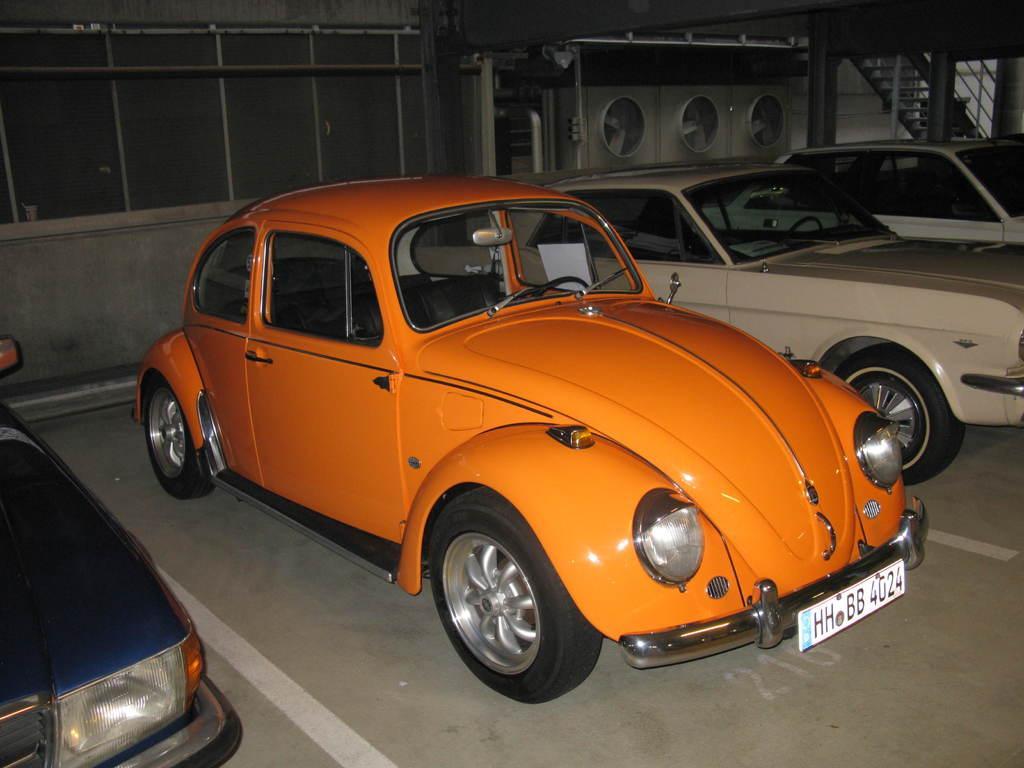How would you summarize this image in a sentence or two? These are the different model cars, which are parked in the parking area. I can see the stairs. These look like a machine. These are the pillars. 